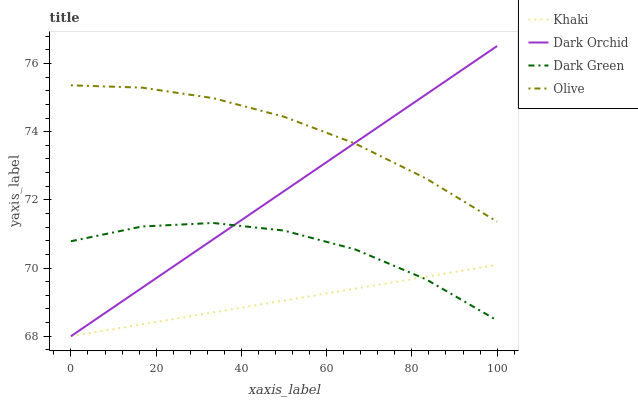Does Khaki have the minimum area under the curve?
Answer yes or no. Yes. Does Olive have the maximum area under the curve?
Answer yes or no. Yes. Does Dark Orchid have the minimum area under the curve?
Answer yes or no. No. Does Dark Orchid have the maximum area under the curve?
Answer yes or no. No. Is Khaki the smoothest?
Answer yes or no. Yes. Is Dark Green the roughest?
Answer yes or no. Yes. Is Dark Orchid the smoothest?
Answer yes or no. No. Is Dark Orchid the roughest?
Answer yes or no. No. Does Dark Green have the lowest value?
Answer yes or no. No. Does Dark Orchid have the highest value?
Answer yes or no. Yes. Does Khaki have the highest value?
Answer yes or no. No. Is Khaki less than Olive?
Answer yes or no. Yes. Is Olive greater than Dark Green?
Answer yes or no. Yes. Does Khaki intersect Olive?
Answer yes or no. No. 